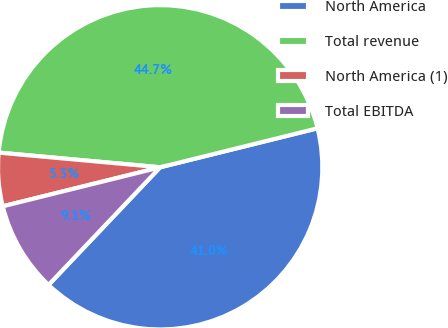Convert chart. <chart><loc_0><loc_0><loc_500><loc_500><pie_chart><fcel>North America<fcel>Total revenue<fcel>North America (1)<fcel>Total EBITDA<nl><fcel>40.95%<fcel>44.69%<fcel>5.31%<fcel>9.05%<nl></chart> 